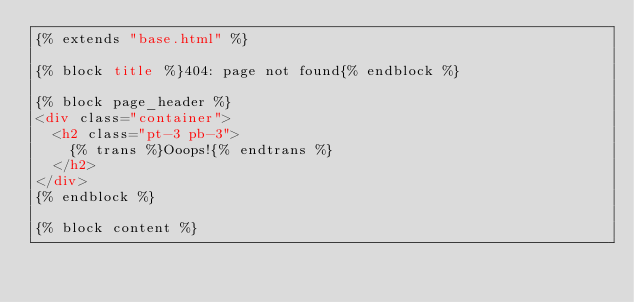<code> <loc_0><loc_0><loc_500><loc_500><_HTML_>{% extends "base.html" %}

{% block title %}404: page not found{% endblock %}

{% block page_header %}
<div class="container">
  <h2 class="pt-3 pb-3">
  	{% trans %}Ooops!{% endtrans %}
  </h2>
</div>
{% endblock %}

{% block content %}</code> 